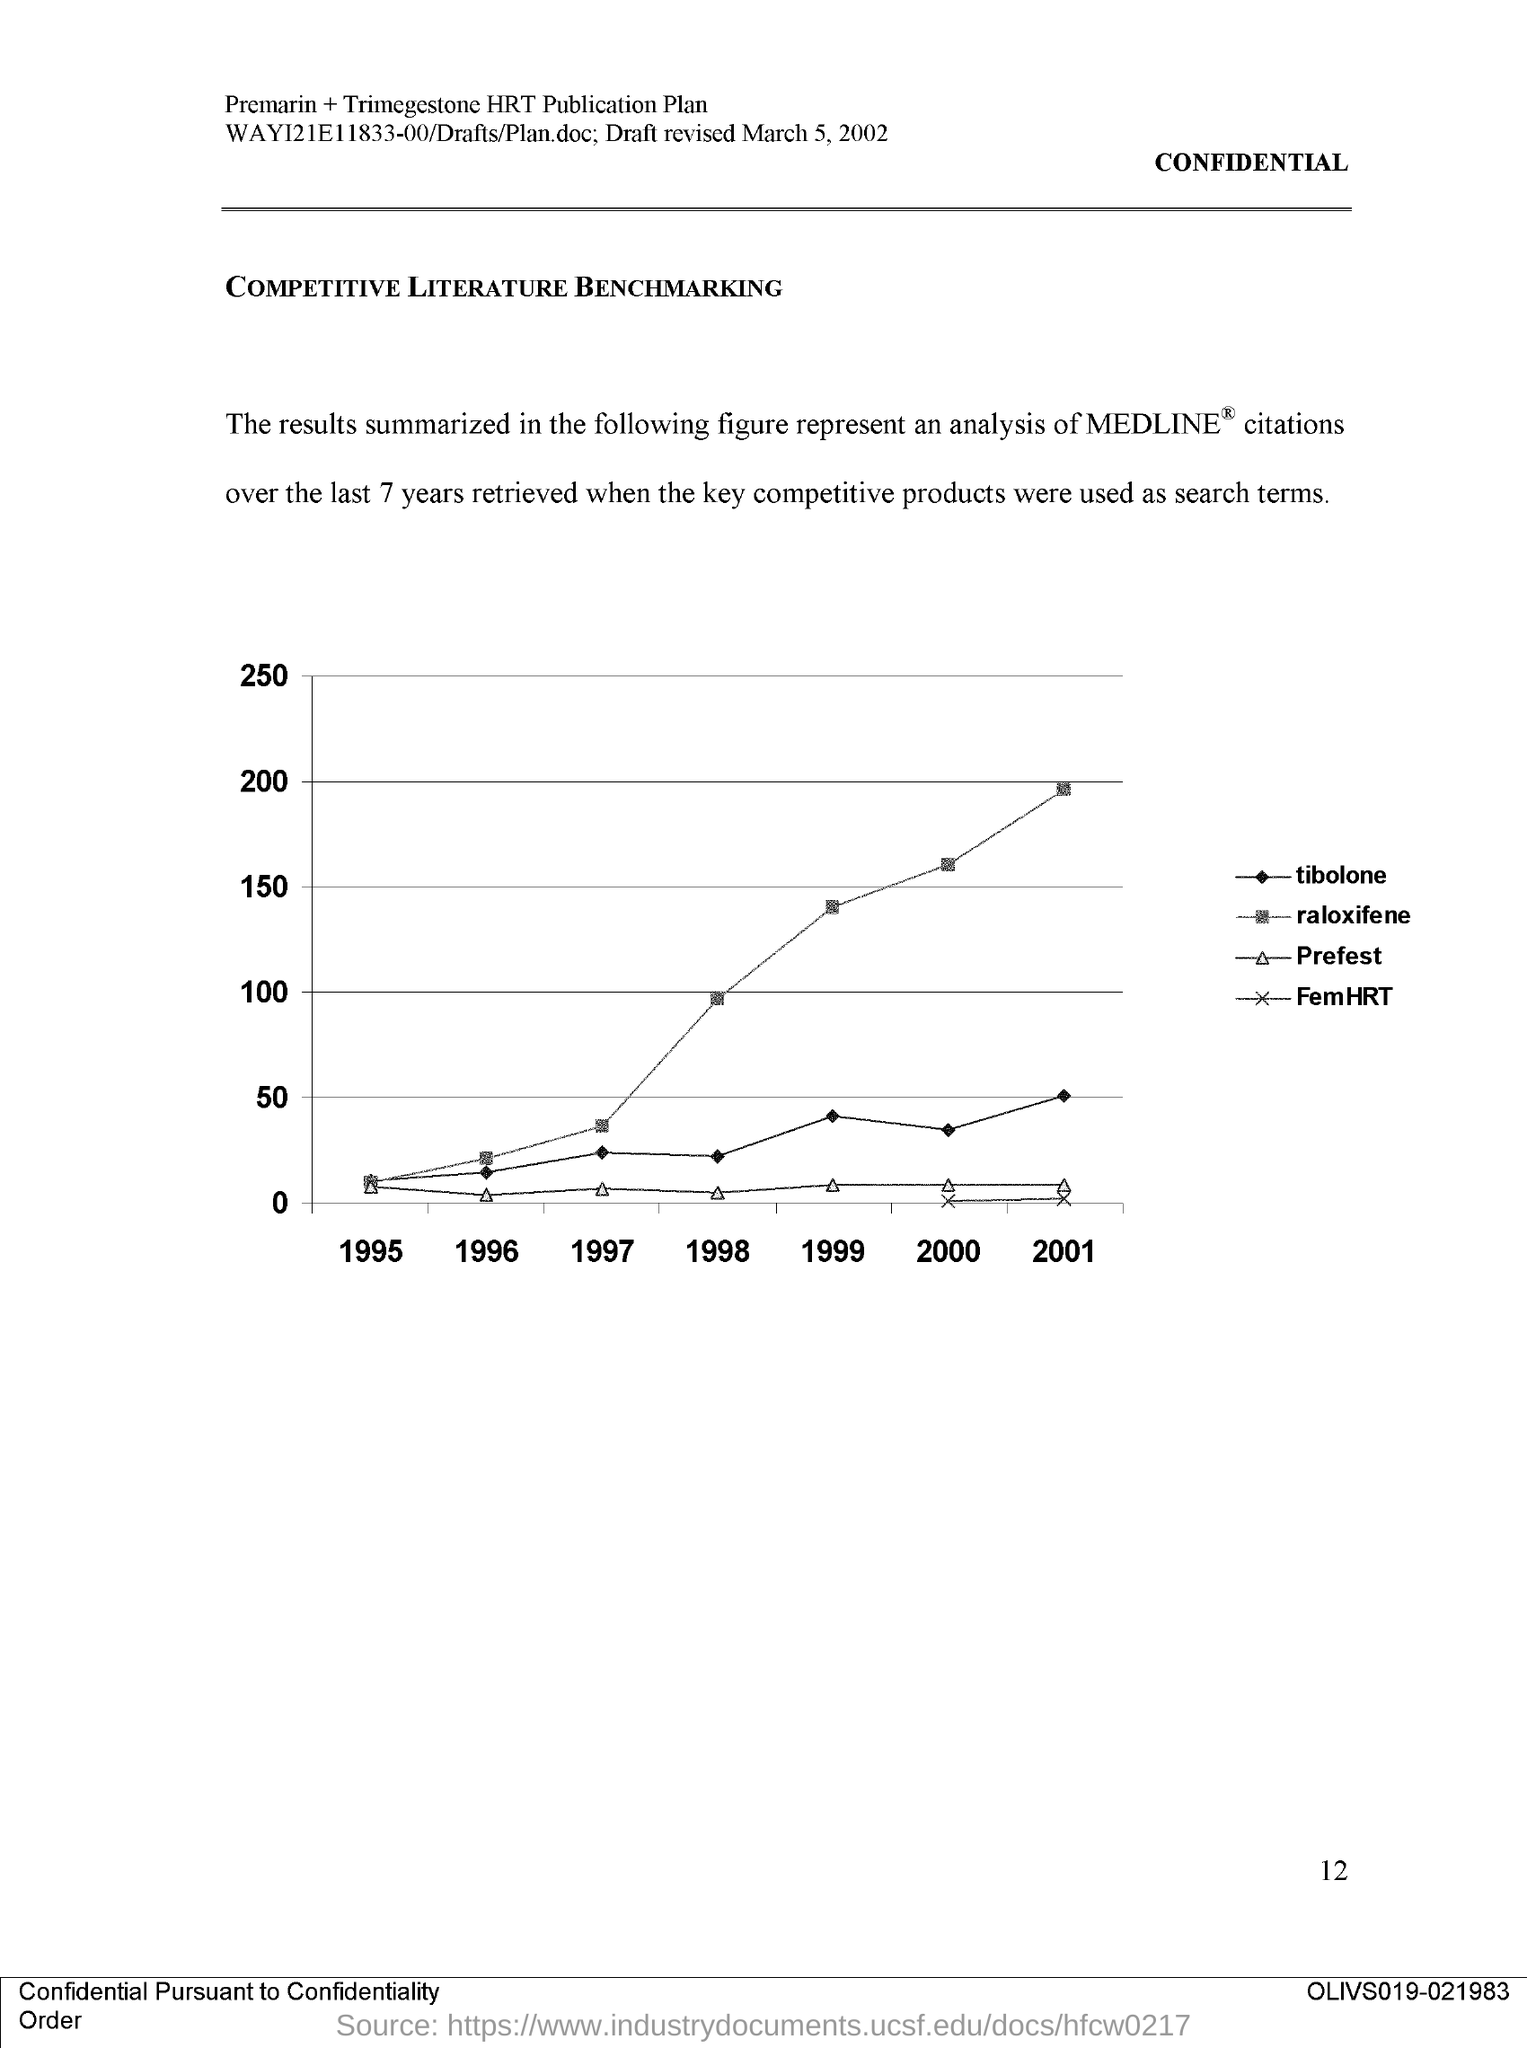List a handful of essential elements in this visual. The page number on this document is 12. The document is titled 'COMPETITIVE LITERATURE BENCHMARKING.' 